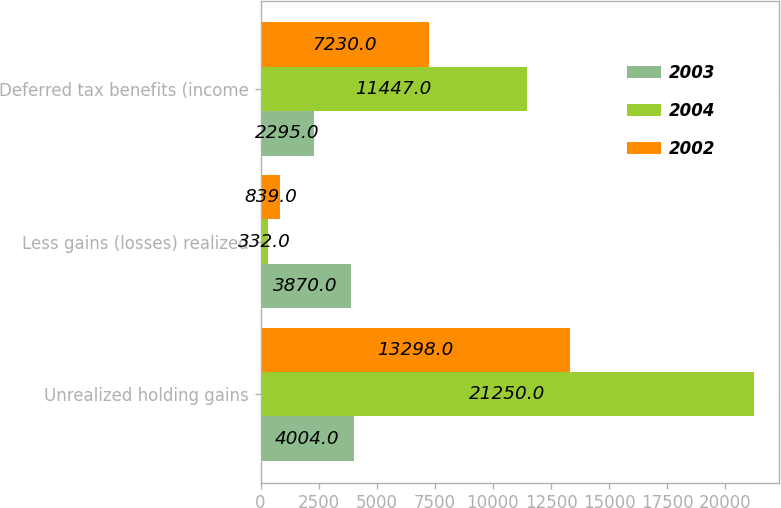Convert chart to OTSL. <chart><loc_0><loc_0><loc_500><loc_500><stacked_bar_chart><ecel><fcel>Unrealized holding gains<fcel>Less gains (losses) realized<fcel>Deferred tax benefits (income<nl><fcel>2003<fcel>4004<fcel>3870<fcel>2295<nl><fcel>2004<fcel>21250<fcel>332<fcel>11447<nl><fcel>2002<fcel>13298<fcel>839<fcel>7230<nl></chart> 